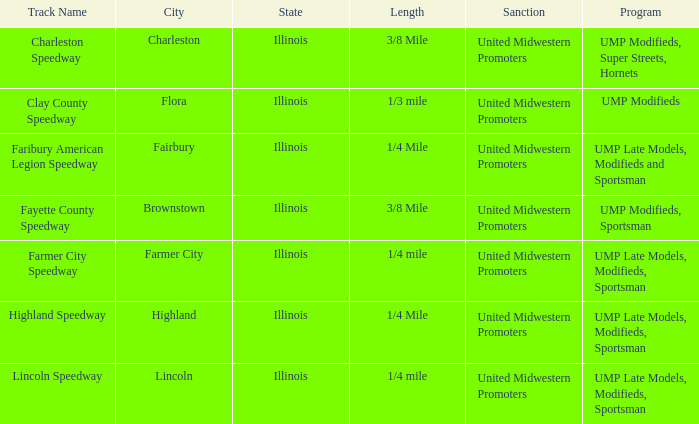What site is farmer city speedway? Farmer City, Illinois. 